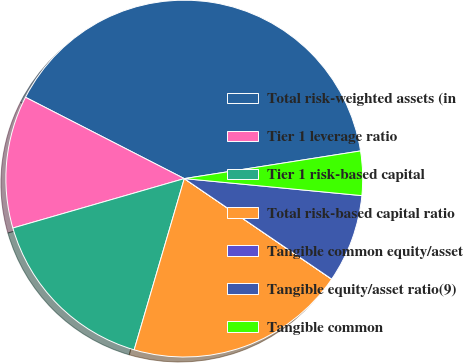Convert chart to OTSL. <chart><loc_0><loc_0><loc_500><loc_500><pie_chart><fcel>Total risk-weighted assets (in<fcel>Tier 1 leverage ratio<fcel>Tier 1 risk-based capital<fcel>Total risk-based capital ratio<fcel>Tangible common equity/asset<fcel>Tangible equity/asset ratio(9)<fcel>Tangible common<nl><fcel>39.99%<fcel>12.0%<fcel>16.0%<fcel>20.0%<fcel>0.01%<fcel>8.0%<fcel>4.0%<nl></chart> 